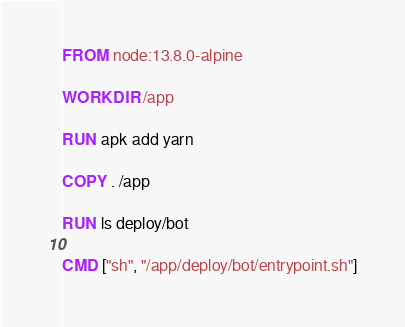<code> <loc_0><loc_0><loc_500><loc_500><_Dockerfile_>FROM node:13.8.0-alpine

WORKDIR /app

RUN apk add yarn

COPY . /app

RUN ls deploy/bot

CMD ["sh", "/app/deploy/bot/entrypoint.sh"]
</code> 